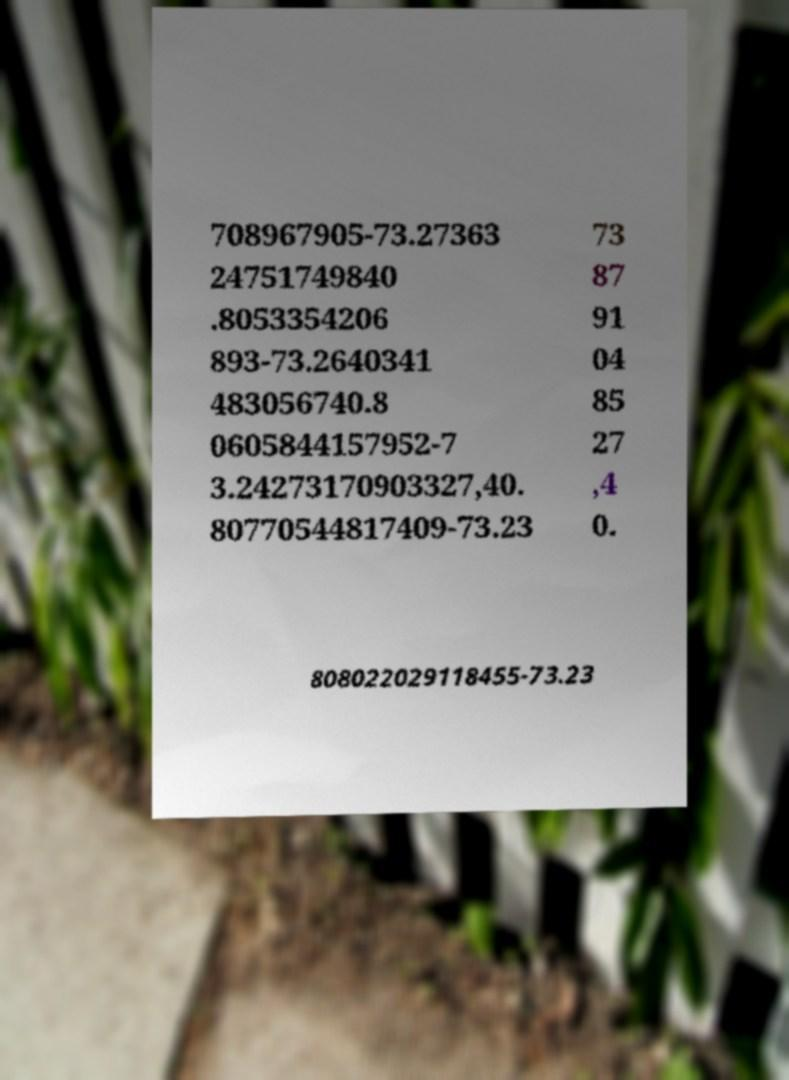Could you assist in decoding the text presented in this image and type it out clearly? 708967905-73.27363 24751749840 .8053354206 893-73.2640341 483056740.8 0605844157952-7 3.24273170903327,40. 80770544817409-73.23 73 87 91 04 85 27 ,4 0. 808022029118455-73.23 